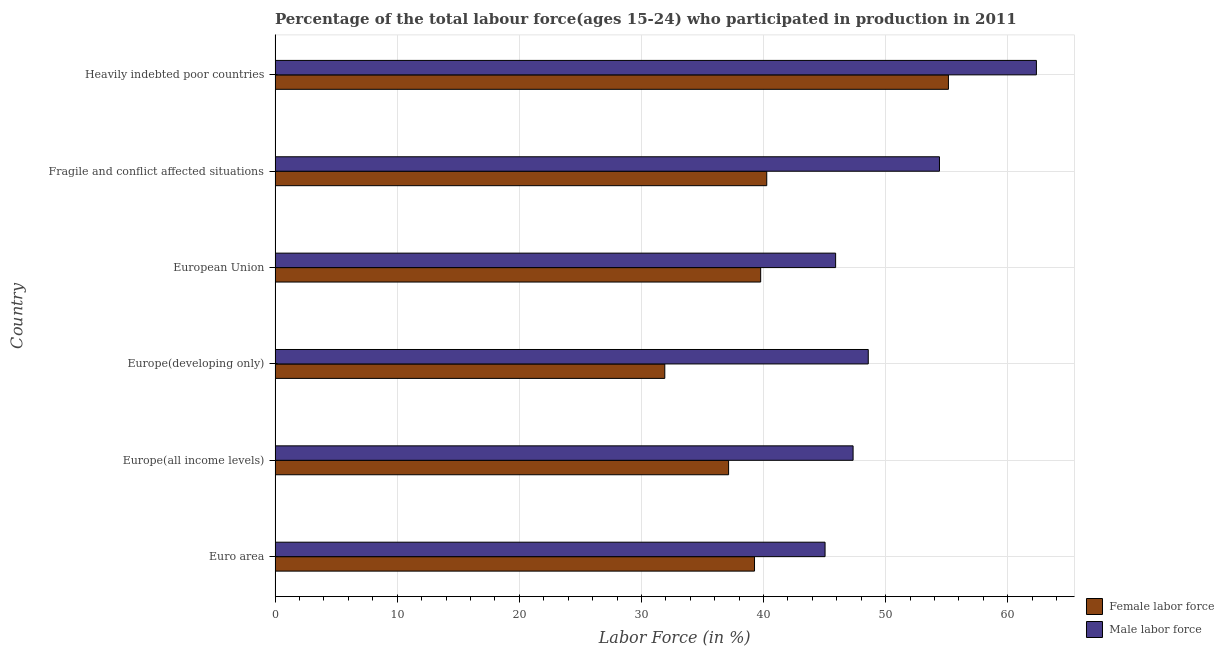How many different coloured bars are there?
Offer a very short reply. 2. Are the number of bars per tick equal to the number of legend labels?
Give a very brief answer. Yes. What is the label of the 2nd group of bars from the top?
Provide a short and direct response. Fragile and conflict affected situations. In how many cases, is the number of bars for a given country not equal to the number of legend labels?
Your answer should be very brief. 0. What is the percentage of male labour force in European Union?
Make the answer very short. 45.9. Across all countries, what is the maximum percentage of male labour force?
Your answer should be compact. 62.35. Across all countries, what is the minimum percentage of male labour force?
Make the answer very short. 45.04. In which country was the percentage of male labour force maximum?
Your answer should be very brief. Heavily indebted poor countries. In which country was the percentage of female labor force minimum?
Ensure brevity in your answer.  Europe(developing only). What is the total percentage of female labor force in the graph?
Your response must be concise. 243.48. What is the difference between the percentage of male labour force in Euro area and that in Europe(developing only)?
Your answer should be compact. -3.54. What is the difference between the percentage of male labour force in Euro area and the percentage of female labor force in Heavily indebted poor countries?
Give a very brief answer. -10.1. What is the average percentage of female labor force per country?
Offer a very short reply. 40.58. What is the difference between the percentage of male labour force and percentage of female labor force in Heavily indebted poor countries?
Give a very brief answer. 7.2. In how many countries, is the percentage of male labour force greater than 42 %?
Provide a succinct answer. 6. Is the percentage of male labour force in Europe(developing only) less than that in Heavily indebted poor countries?
Your answer should be very brief. Yes. What is the difference between the highest and the second highest percentage of male labour force?
Ensure brevity in your answer.  7.94. What is the difference between the highest and the lowest percentage of male labour force?
Make the answer very short. 17.31. In how many countries, is the percentage of male labour force greater than the average percentage of male labour force taken over all countries?
Your answer should be very brief. 2. What does the 2nd bar from the top in Europe(all income levels) represents?
Your response must be concise. Female labor force. What does the 1st bar from the bottom in Europe(all income levels) represents?
Provide a short and direct response. Female labor force. Are all the bars in the graph horizontal?
Your answer should be compact. Yes. How many countries are there in the graph?
Ensure brevity in your answer.  6. What is the difference between two consecutive major ticks on the X-axis?
Ensure brevity in your answer.  10. Does the graph contain any zero values?
Your response must be concise. No. Does the graph contain grids?
Provide a succinct answer. Yes. What is the title of the graph?
Ensure brevity in your answer.  Percentage of the total labour force(ages 15-24) who participated in production in 2011. What is the label or title of the Y-axis?
Your response must be concise. Country. What is the Labor Force (in %) in Female labor force in Euro area?
Ensure brevity in your answer.  39.26. What is the Labor Force (in %) in Male labor force in Euro area?
Provide a short and direct response. 45.04. What is the Labor Force (in %) in Female labor force in Europe(all income levels)?
Your answer should be compact. 37.14. What is the Labor Force (in %) of Male labor force in Europe(all income levels)?
Give a very brief answer. 47.33. What is the Labor Force (in %) in Female labor force in Europe(developing only)?
Ensure brevity in your answer.  31.91. What is the Labor Force (in %) in Male labor force in Europe(developing only)?
Your response must be concise. 48.58. What is the Labor Force (in %) in Female labor force in European Union?
Offer a terse response. 39.76. What is the Labor Force (in %) of Male labor force in European Union?
Your answer should be very brief. 45.9. What is the Labor Force (in %) in Female labor force in Fragile and conflict affected situations?
Make the answer very short. 40.26. What is the Labor Force (in %) of Male labor force in Fragile and conflict affected situations?
Offer a terse response. 54.41. What is the Labor Force (in %) in Female labor force in Heavily indebted poor countries?
Provide a succinct answer. 55.14. What is the Labor Force (in %) of Male labor force in Heavily indebted poor countries?
Ensure brevity in your answer.  62.35. Across all countries, what is the maximum Labor Force (in %) of Female labor force?
Offer a terse response. 55.14. Across all countries, what is the maximum Labor Force (in %) in Male labor force?
Offer a terse response. 62.35. Across all countries, what is the minimum Labor Force (in %) of Female labor force?
Your response must be concise. 31.91. Across all countries, what is the minimum Labor Force (in %) in Male labor force?
Give a very brief answer. 45.04. What is the total Labor Force (in %) of Female labor force in the graph?
Provide a short and direct response. 243.48. What is the total Labor Force (in %) in Male labor force in the graph?
Provide a short and direct response. 303.6. What is the difference between the Labor Force (in %) in Female labor force in Euro area and that in Europe(all income levels)?
Offer a terse response. 2.12. What is the difference between the Labor Force (in %) of Male labor force in Euro area and that in Europe(all income levels)?
Your answer should be very brief. -2.3. What is the difference between the Labor Force (in %) of Female labor force in Euro area and that in Europe(developing only)?
Your answer should be very brief. 7.35. What is the difference between the Labor Force (in %) of Male labor force in Euro area and that in Europe(developing only)?
Ensure brevity in your answer.  -3.54. What is the difference between the Labor Force (in %) of Female labor force in Euro area and that in European Union?
Provide a short and direct response. -0.5. What is the difference between the Labor Force (in %) in Male labor force in Euro area and that in European Union?
Offer a terse response. -0.86. What is the difference between the Labor Force (in %) in Female labor force in Euro area and that in Fragile and conflict affected situations?
Give a very brief answer. -1. What is the difference between the Labor Force (in %) of Male labor force in Euro area and that in Fragile and conflict affected situations?
Ensure brevity in your answer.  -9.37. What is the difference between the Labor Force (in %) in Female labor force in Euro area and that in Heavily indebted poor countries?
Offer a very short reply. -15.88. What is the difference between the Labor Force (in %) of Male labor force in Euro area and that in Heavily indebted poor countries?
Keep it short and to the point. -17.31. What is the difference between the Labor Force (in %) in Female labor force in Europe(all income levels) and that in Europe(developing only)?
Offer a terse response. 5.22. What is the difference between the Labor Force (in %) of Male labor force in Europe(all income levels) and that in Europe(developing only)?
Provide a succinct answer. -1.24. What is the difference between the Labor Force (in %) in Female labor force in Europe(all income levels) and that in European Union?
Keep it short and to the point. -2.63. What is the difference between the Labor Force (in %) in Male labor force in Europe(all income levels) and that in European Union?
Your answer should be very brief. 1.43. What is the difference between the Labor Force (in %) in Female labor force in Europe(all income levels) and that in Fragile and conflict affected situations?
Make the answer very short. -3.13. What is the difference between the Labor Force (in %) in Male labor force in Europe(all income levels) and that in Fragile and conflict affected situations?
Ensure brevity in your answer.  -7.07. What is the difference between the Labor Force (in %) in Female labor force in Europe(all income levels) and that in Heavily indebted poor countries?
Provide a succinct answer. -18. What is the difference between the Labor Force (in %) in Male labor force in Europe(all income levels) and that in Heavily indebted poor countries?
Offer a terse response. -15.01. What is the difference between the Labor Force (in %) of Female labor force in Europe(developing only) and that in European Union?
Make the answer very short. -7.85. What is the difference between the Labor Force (in %) of Male labor force in Europe(developing only) and that in European Union?
Give a very brief answer. 2.67. What is the difference between the Labor Force (in %) in Female labor force in Europe(developing only) and that in Fragile and conflict affected situations?
Offer a very short reply. -8.35. What is the difference between the Labor Force (in %) in Male labor force in Europe(developing only) and that in Fragile and conflict affected situations?
Keep it short and to the point. -5.83. What is the difference between the Labor Force (in %) of Female labor force in Europe(developing only) and that in Heavily indebted poor countries?
Offer a terse response. -23.23. What is the difference between the Labor Force (in %) of Male labor force in Europe(developing only) and that in Heavily indebted poor countries?
Offer a very short reply. -13.77. What is the difference between the Labor Force (in %) in Female labor force in European Union and that in Fragile and conflict affected situations?
Offer a terse response. -0.5. What is the difference between the Labor Force (in %) of Male labor force in European Union and that in Fragile and conflict affected situations?
Your response must be concise. -8.5. What is the difference between the Labor Force (in %) of Female labor force in European Union and that in Heavily indebted poor countries?
Your response must be concise. -15.38. What is the difference between the Labor Force (in %) of Male labor force in European Union and that in Heavily indebted poor countries?
Make the answer very short. -16.44. What is the difference between the Labor Force (in %) in Female labor force in Fragile and conflict affected situations and that in Heavily indebted poor countries?
Provide a succinct answer. -14.88. What is the difference between the Labor Force (in %) of Male labor force in Fragile and conflict affected situations and that in Heavily indebted poor countries?
Provide a succinct answer. -7.94. What is the difference between the Labor Force (in %) in Female labor force in Euro area and the Labor Force (in %) in Male labor force in Europe(all income levels)?
Give a very brief answer. -8.07. What is the difference between the Labor Force (in %) of Female labor force in Euro area and the Labor Force (in %) of Male labor force in Europe(developing only)?
Give a very brief answer. -9.31. What is the difference between the Labor Force (in %) in Female labor force in Euro area and the Labor Force (in %) in Male labor force in European Union?
Make the answer very short. -6.64. What is the difference between the Labor Force (in %) of Female labor force in Euro area and the Labor Force (in %) of Male labor force in Fragile and conflict affected situations?
Provide a short and direct response. -15.14. What is the difference between the Labor Force (in %) of Female labor force in Euro area and the Labor Force (in %) of Male labor force in Heavily indebted poor countries?
Provide a short and direct response. -23.08. What is the difference between the Labor Force (in %) of Female labor force in Europe(all income levels) and the Labor Force (in %) of Male labor force in Europe(developing only)?
Provide a short and direct response. -11.44. What is the difference between the Labor Force (in %) in Female labor force in Europe(all income levels) and the Labor Force (in %) in Male labor force in European Union?
Keep it short and to the point. -8.76. What is the difference between the Labor Force (in %) in Female labor force in Europe(all income levels) and the Labor Force (in %) in Male labor force in Fragile and conflict affected situations?
Ensure brevity in your answer.  -17.27. What is the difference between the Labor Force (in %) in Female labor force in Europe(all income levels) and the Labor Force (in %) in Male labor force in Heavily indebted poor countries?
Your response must be concise. -25.21. What is the difference between the Labor Force (in %) of Female labor force in Europe(developing only) and the Labor Force (in %) of Male labor force in European Union?
Provide a short and direct response. -13.99. What is the difference between the Labor Force (in %) of Female labor force in Europe(developing only) and the Labor Force (in %) of Male labor force in Fragile and conflict affected situations?
Provide a short and direct response. -22.49. What is the difference between the Labor Force (in %) in Female labor force in Europe(developing only) and the Labor Force (in %) in Male labor force in Heavily indebted poor countries?
Offer a very short reply. -30.43. What is the difference between the Labor Force (in %) in Female labor force in European Union and the Labor Force (in %) in Male labor force in Fragile and conflict affected situations?
Offer a very short reply. -14.64. What is the difference between the Labor Force (in %) in Female labor force in European Union and the Labor Force (in %) in Male labor force in Heavily indebted poor countries?
Your answer should be compact. -22.58. What is the difference between the Labor Force (in %) of Female labor force in Fragile and conflict affected situations and the Labor Force (in %) of Male labor force in Heavily indebted poor countries?
Offer a very short reply. -22.08. What is the average Labor Force (in %) of Female labor force per country?
Provide a succinct answer. 40.58. What is the average Labor Force (in %) in Male labor force per country?
Make the answer very short. 50.6. What is the difference between the Labor Force (in %) of Female labor force and Labor Force (in %) of Male labor force in Euro area?
Ensure brevity in your answer.  -5.78. What is the difference between the Labor Force (in %) of Female labor force and Labor Force (in %) of Male labor force in Europe(all income levels)?
Keep it short and to the point. -10.2. What is the difference between the Labor Force (in %) in Female labor force and Labor Force (in %) in Male labor force in Europe(developing only)?
Your answer should be compact. -16.66. What is the difference between the Labor Force (in %) in Female labor force and Labor Force (in %) in Male labor force in European Union?
Provide a succinct answer. -6.14. What is the difference between the Labor Force (in %) of Female labor force and Labor Force (in %) of Male labor force in Fragile and conflict affected situations?
Your answer should be very brief. -14.14. What is the difference between the Labor Force (in %) of Female labor force and Labor Force (in %) of Male labor force in Heavily indebted poor countries?
Ensure brevity in your answer.  -7.2. What is the ratio of the Labor Force (in %) in Female labor force in Euro area to that in Europe(all income levels)?
Your response must be concise. 1.06. What is the ratio of the Labor Force (in %) of Male labor force in Euro area to that in Europe(all income levels)?
Ensure brevity in your answer.  0.95. What is the ratio of the Labor Force (in %) in Female labor force in Euro area to that in Europe(developing only)?
Make the answer very short. 1.23. What is the ratio of the Labor Force (in %) in Male labor force in Euro area to that in Europe(developing only)?
Offer a terse response. 0.93. What is the ratio of the Labor Force (in %) in Female labor force in Euro area to that in European Union?
Keep it short and to the point. 0.99. What is the ratio of the Labor Force (in %) of Male labor force in Euro area to that in European Union?
Offer a very short reply. 0.98. What is the ratio of the Labor Force (in %) in Female labor force in Euro area to that in Fragile and conflict affected situations?
Your answer should be very brief. 0.98. What is the ratio of the Labor Force (in %) of Male labor force in Euro area to that in Fragile and conflict affected situations?
Ensure brevity in your answer.  0.83. What is the ratio of the Labor Force (in %) of Female labor force in Euro area to that in Heavily indebted poor countries?
Your response must be concise. 0.71. What is the ratio of the Labor Force (in %) of Male labor force in Euro area to that in Heavily indebted poor countries?
Offer a very short reply. 0.72. What is the ratio of the Labor Force (in %) in Female labor force in Europe(all income levels) to that in Europe(developing only)?
Ensure brevity in your answer.  1.16. What is the ratio of the Labor Force (in %) in Male labor force in Europe(all income levels) to that in Europe(developing only)?
Offer a terse response. 0.97. What is the ratio of the Labor Force (in %) of Female labor force in Europe(all income levels) to that in European Union?
Offer a terse response. 0.93. What is the ratio of the Labor Force (in %) of Male labor force in Europe(all income levels) to that in European Union?
Ensure brevity in your answer.  1.03. What is the ratio of the Labor Force (in %) in Female labor force in Europe(all income levels) to that in Fragile and conflict affected situations?
Offer a very short reply. 0.92. What is the ratio of the Labor Force (in %) in Male labor force in Europe(all income levels) to that in Fragile and conflict affected situations?
Offer a very short reply. 0.87. What is the ratio of the Labor Force (in %) in Female labor force in Europe(all income levels) to that in Heavily indebted poor countries?
Provide a short and direct response. 0.67. What is the ratio of the Labor Force (in %) in Male labor force in Europe(all income levels) to that in Heavily indebted poor countries?
Offer a terse response. 0.76. What is the ratio of the Labor Force (in %) of Female labor force in Europe(developing only) to that in European Union?
Provide a succinct answer. 0.8. What is the ratio of the Labor Force (in %) of Male labor force in Europe(developing only) to that in European Union?
Ensure brevity in your answer.  1.06. What is the ratio of the Labor Force (in %) in Female labor force in Europe(developing only) to that in Fragile and conflict affected situations?
Offer a very short reply. 0.79. What is the ratio of the Labor Force (in %) in Male labor force in Europe(developing only) to that in Fragile and conflict affected situations?
Your answer should be compact. 0.89. What is the ratio of the Labor Force (in %) of Female labor force in Europe(developing only) to that in Heavily indebted poor countries?
Keep it short and to the point. 0.58. What is the ratio of the Labor Force (in %) of Male labor force in Europe(developing only) to that in Heavily indebted poor countries?
Make the answer very short. 0.78. What is the ratio of the Labor Force (in %) of Female labor force in European Union to that in Fragile and conflict affected situations?
Your answer should be very brief. 0.99. What is the ratio of the Labor Force (in %) of Male labor force in European Union to that in Fragile and conflict affected situations?
Provide a short and direct response. 0.84. What is the ratio of the Labor Force (in %) in Female labor force in European Union to that in Heavily indebted poor countries?
Give a very brief answer. 0.72. What is the ratio of the Labor Force (in %) of Male labor force in European Union to that in Heavily indebted poor countries?
Make the answer very short. 0.74. What is the ratio of the Labor Force (in %) of Female labor force in Fragile and conflict affected situations to that in Heavily indebted poor countries?
Make the answer very short. 0.73. What is the ratio of the Labor Force (in %) of Male labor force in Fragile and conflict affected situations to that in Heavily indebted poor countries?
Offer a terse response. 0.87. What is the difference between the highest and the second highest Labor Force (in %) of Female labor force?
Keep it short and to the point. 14.88. What is the difference between the highest and the second highest Labor Force (in %) in Male labor force?
Keep it short and to the point. 7.94. What is the difference between the highest and the lowest Labor Force (in %) of Female labor force?
Your answer should be very brief. 23.23. What is the difference between the highest and the lowest Labor Force (in %) of Male labor force?
Make the answer very short. 17.31. 